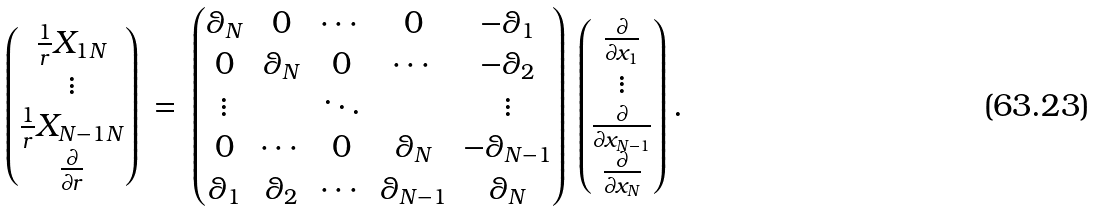Convert formula to latex. <formula><loc_0><loc_0><loc_500><loc_500>\begin{pmatrix} \frac { 1 } { r } X _ { 1 N } \\ \vdots \\ \frac { 1 } { r } X _ { N - 1 N } \\ \frac { \partial } { \partial r } \end{pmatrix} \, = \, \begin{pmatrix} \theta _ { N } & 0 & \cdots & 0 & - \theta _ { 1 } \\ 0 & \theta _ { N } & 0 & \cdots & - \theta _ { 2 } \\ \vdots & & \ddots & & \vdots \\ 0 & \cdots & 0 & \theta _ { N } & - \theta _ { N - 1 } \\ \theta _ { 1 } & \theta _ { 2 } & \cdots & \theta _ { N - 1 } & \theta _ { N } \end{pmatrix} \, \begin{pmatrix} \frac { \partial } { \partial x _ { 1 } } \\ \vdots \\ \frac { \partial } { \partial x _ { N - 1 } } \\ \frac { \partial } { \partial x _ { N } } \\ \end{pmatrix} .</formula> 